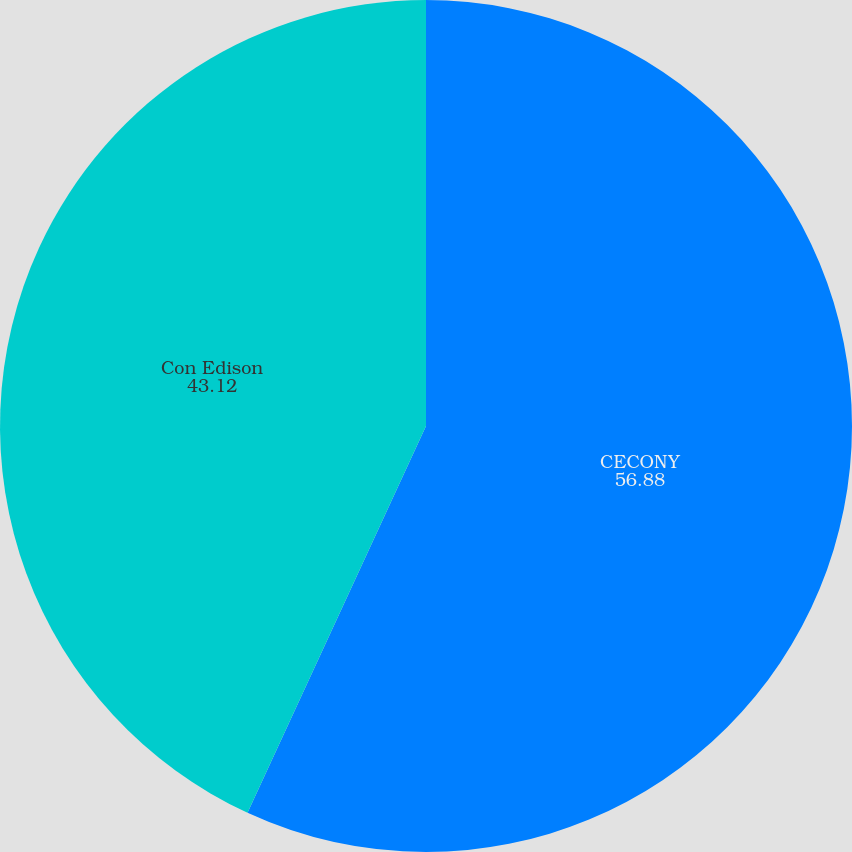Convert chart to OTSL. <chart><loc_0><loc_0><loc_500><loc_500><pie_chart><fcel>CECONY<fcel>Con Edison<nl><fcel>56.88%<fcel>43.12%<nl></chart> 